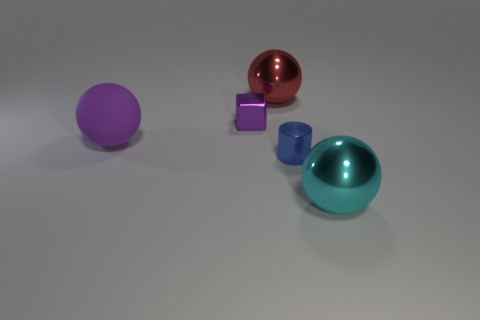Add 1 big red balls. How many objects exist? 6 Subtract 0 blue spheres. How many objects are left? 5 Subtract all spheres. How many objects are left? 2 Subtract all purple shiny cubes. Subtract all rubber things. How many objects are left? 3 Add 1 big red metallic balls. How many big red metallic balls are left? 2 Add 2 big shiny spheres. How many big shiny spheres exist? 4 